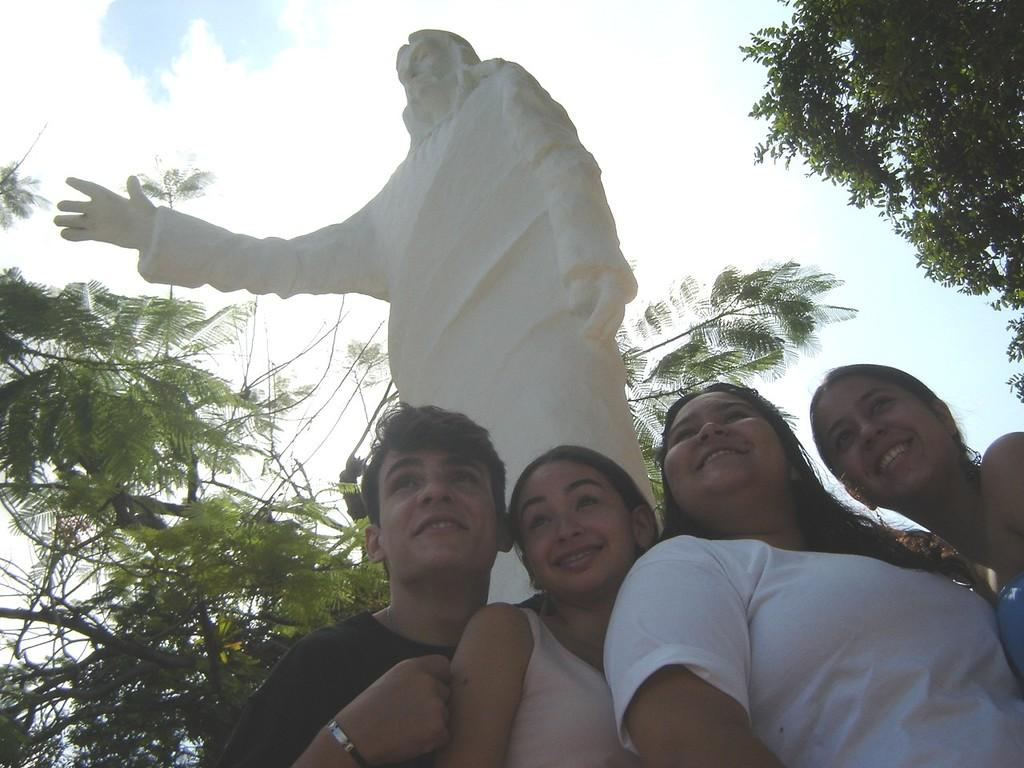How many people are in the image? There are three women and a man in the image. What is the man wearing? The man is wearing a black t-shirt. What are the women doing in the image? The women are standing. What type of natural elements can be seen in the image? There are trees visible in the image. What is the color of the statue in the image? The statue is cream-colored. What can be seen in the background of the image? The sky is visible in the background of the image. How many buns are being held by the ants in the image? There are no ants or buns present in the image. What type of tool is being used by the man to dig in the image? There is no tool, such as a spade, being used by the man in the image. 